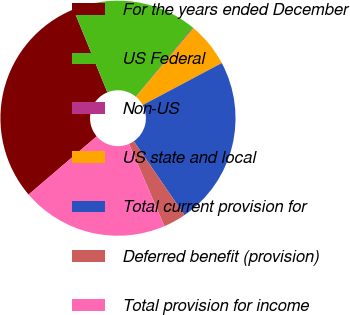<chart> <loc_0><loc_0><loc_500><loc_500><pie_chart><fcel>For the years ended December<fcel>US Federal<fcel>Non-US<fcel>US state and local<fcel>Total current provision for<fcel>Deferred benefit (provision)<fcel>Total provision for income<nl><fcel>30.07%<fcel>17.21%<fcel>0.1%<fcel>6.1%<fcel>23.21%<fcel>3.1%<fcel>20.21%<nl></chart> 